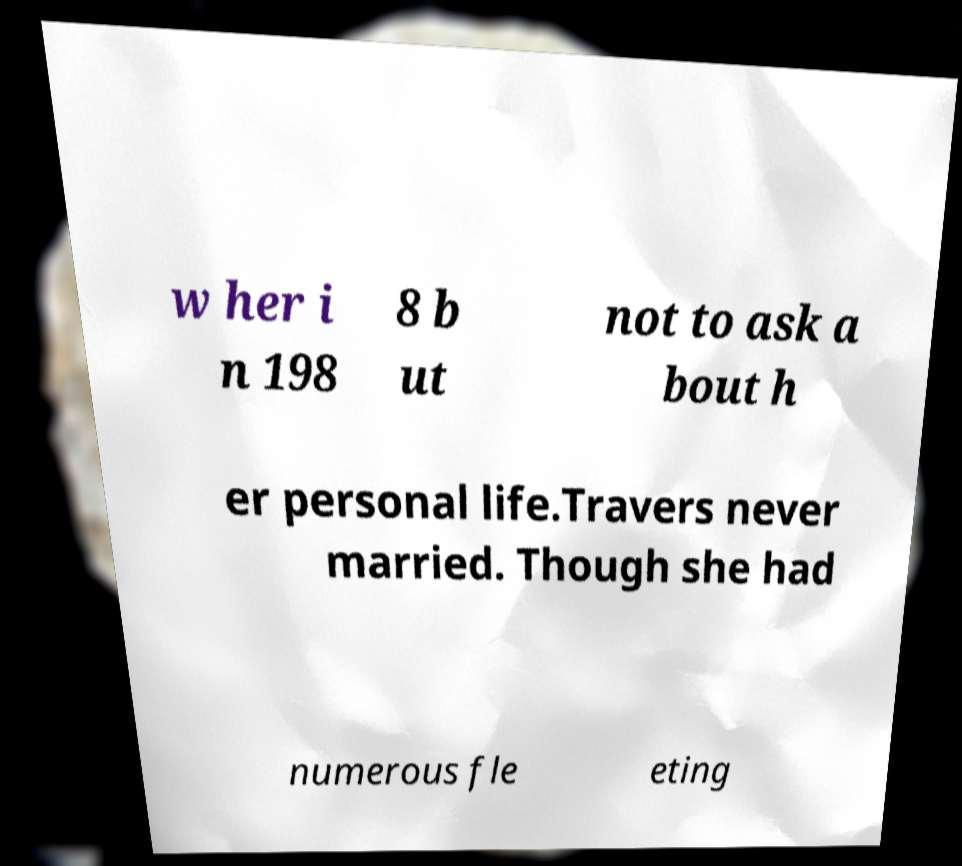There's text embedded in this image that I need extracted. Can you transcribe it verbatim? w her i n 198 8 b ut not to ask a bout h er personal life.Travers never married. Though she had numerous fle eting 